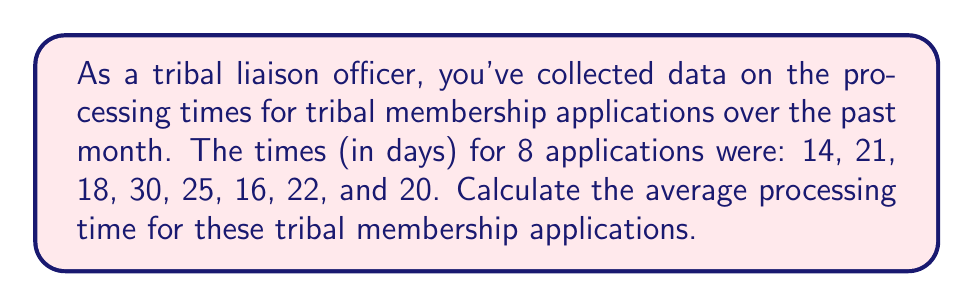Teach me how to tackle this problem. To calculate the average processing time, we need to follow these steps:

1. Sum up all the processing times:
   $$ \text{Sum} = 14 + 21 + 18 + 30 + 25 + 16 + 22 + 20 $$
   $$ \text{Sum} = 166 \text{ days} $$

2. Count the total number of applications:
   $$ n = 8 $$

3. Calculate the average (mean) by dividing the sum by the number of applications:
   $$ \text{Average} = \frac{\text{Sum}}{n} = \frac{166}{8} = 20.75 \text{ days} $$

Therefore, the average processing time for tribal membership applications is 20.75 days.
Answer: 20.75 days 